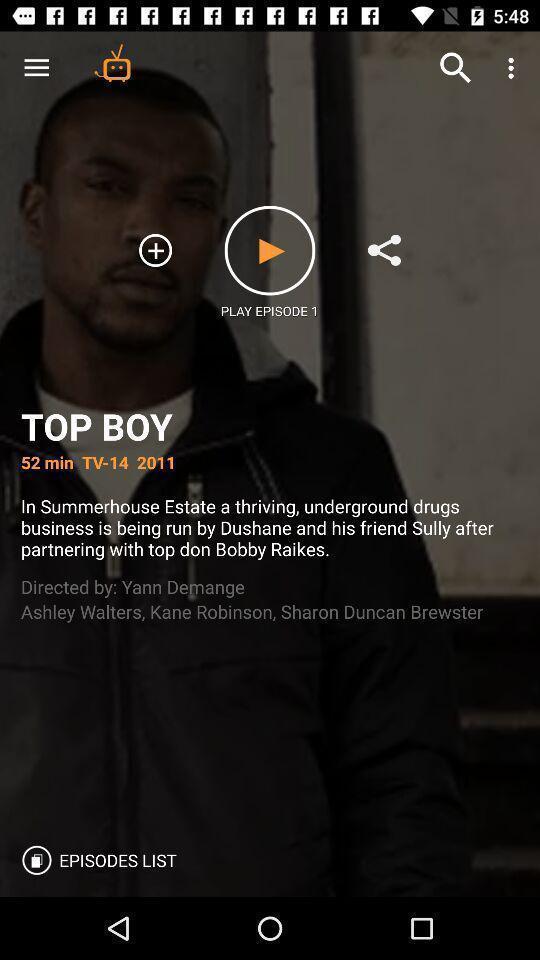Provide a description of this screenshot. Video play page of a series. 